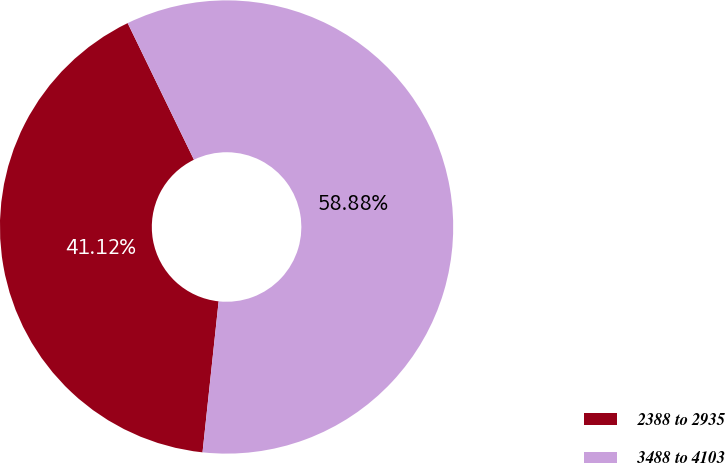Convert chart. <chart><loc_0><loc_0><loc_500><loc_500><pie_chart><fcel>2388 to 2935<fcel>3488 to 4103<nl><fcel>41.12%<fcel>58.88%<nl></chart> 